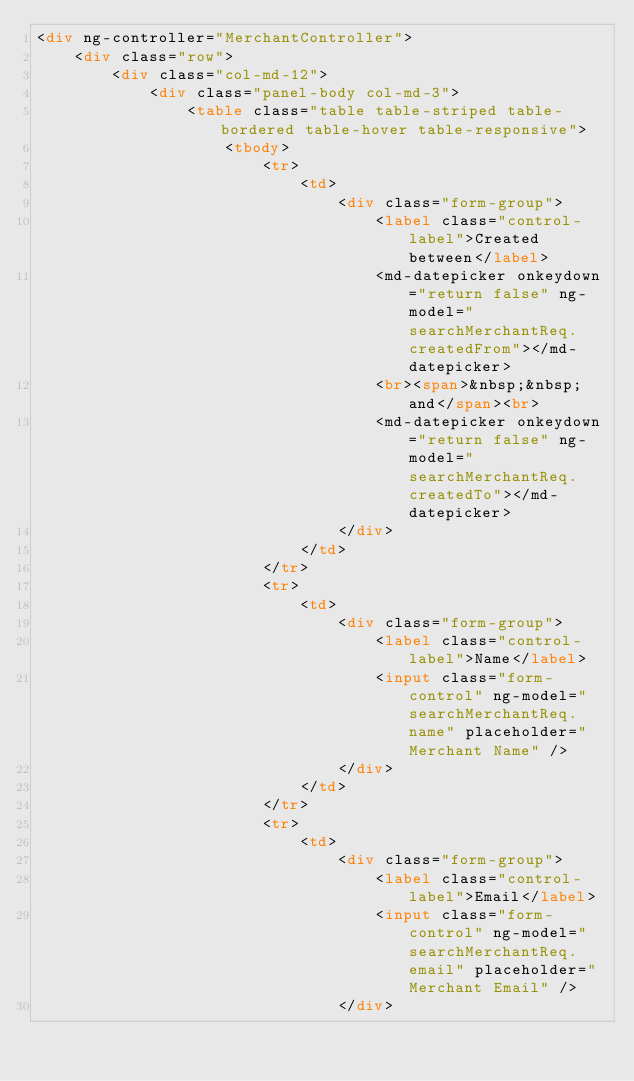Convert code to text. <code><loc_0><loc_0><loc_500><loc_500><_HTML_><div ng-controller="MerchantController">
	<div class="row">
		<div class="col-md-12">
			<div class="panel-body col-md-3">
				<table class="table table-striped table-bordered table-hover table-responsive">
					<tbody>
						<tr>
							<td>
								<div class="form-group">
									<label class="control-label">Created between</label>
									<md-datepicker onkeydown="return false" ng-model="searchMerchantReq.createdFrom"></md-datepicker>
									<br><span>&nbsp;&nbsp;and</span><br>
									<md-datepicker onkeydown="return false" ng-model="searchMerchantReq.createdTo"></md-datepicker>
								</div>
							</td>
						</tr>
						<tr>
							<td>
								<div class="form-group">
									<label class="control-label">Name</label>
									<input class="form-control" ng-model="searchMerchantReq.name" placeholder="Merchant Name" />
								</div>
							</td>
						</tr>
						<tr>
							<td>
								<div class="form-group">
									<label class="control-label">Email</label>
									<input class="form-control" ng-model="searchMerchantReq.email" placeholder="Merchant Email" />
								</div></code> 